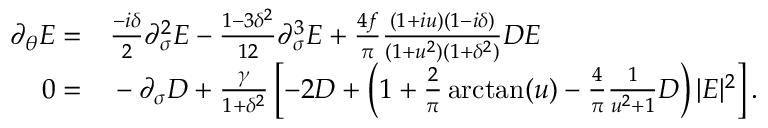Convert formula to latex. <formula><loc_0><loc_0><loc_500><loc_500>\begin{array} { r l } { \partial _ { \theta } E = } & \frac { - i \delta } { 2 } \partial _ { \sigma } ^ { 2 } E - \frac { 1 - 3 \delta ^ { 2 } } { 1 2 } \partial _ { \sigma } ^ { 3 } E + \frac { 4 f } { \pi } \frac { ( 1 + i u ) ( 1 - i \delta ) } { ( 1 + u ^ { 2 } ) ( 1 + \delta ^ { 2 } ) } D E } \\ { 0 = } & - \partial _ { \sigma } D + \frac { \gamma } { 1 + \delta ^ { 2 } } \left [ - 2 D + \left ( 1 + \frac { 2 } { \pi } \arctan ( u ) - \frac { 4 } { \pi } \frac { 1 } { u ^ { 2 } + 1 } D \right ) | E | ^ { 2 } \right ] . } \end{array}</formula> 